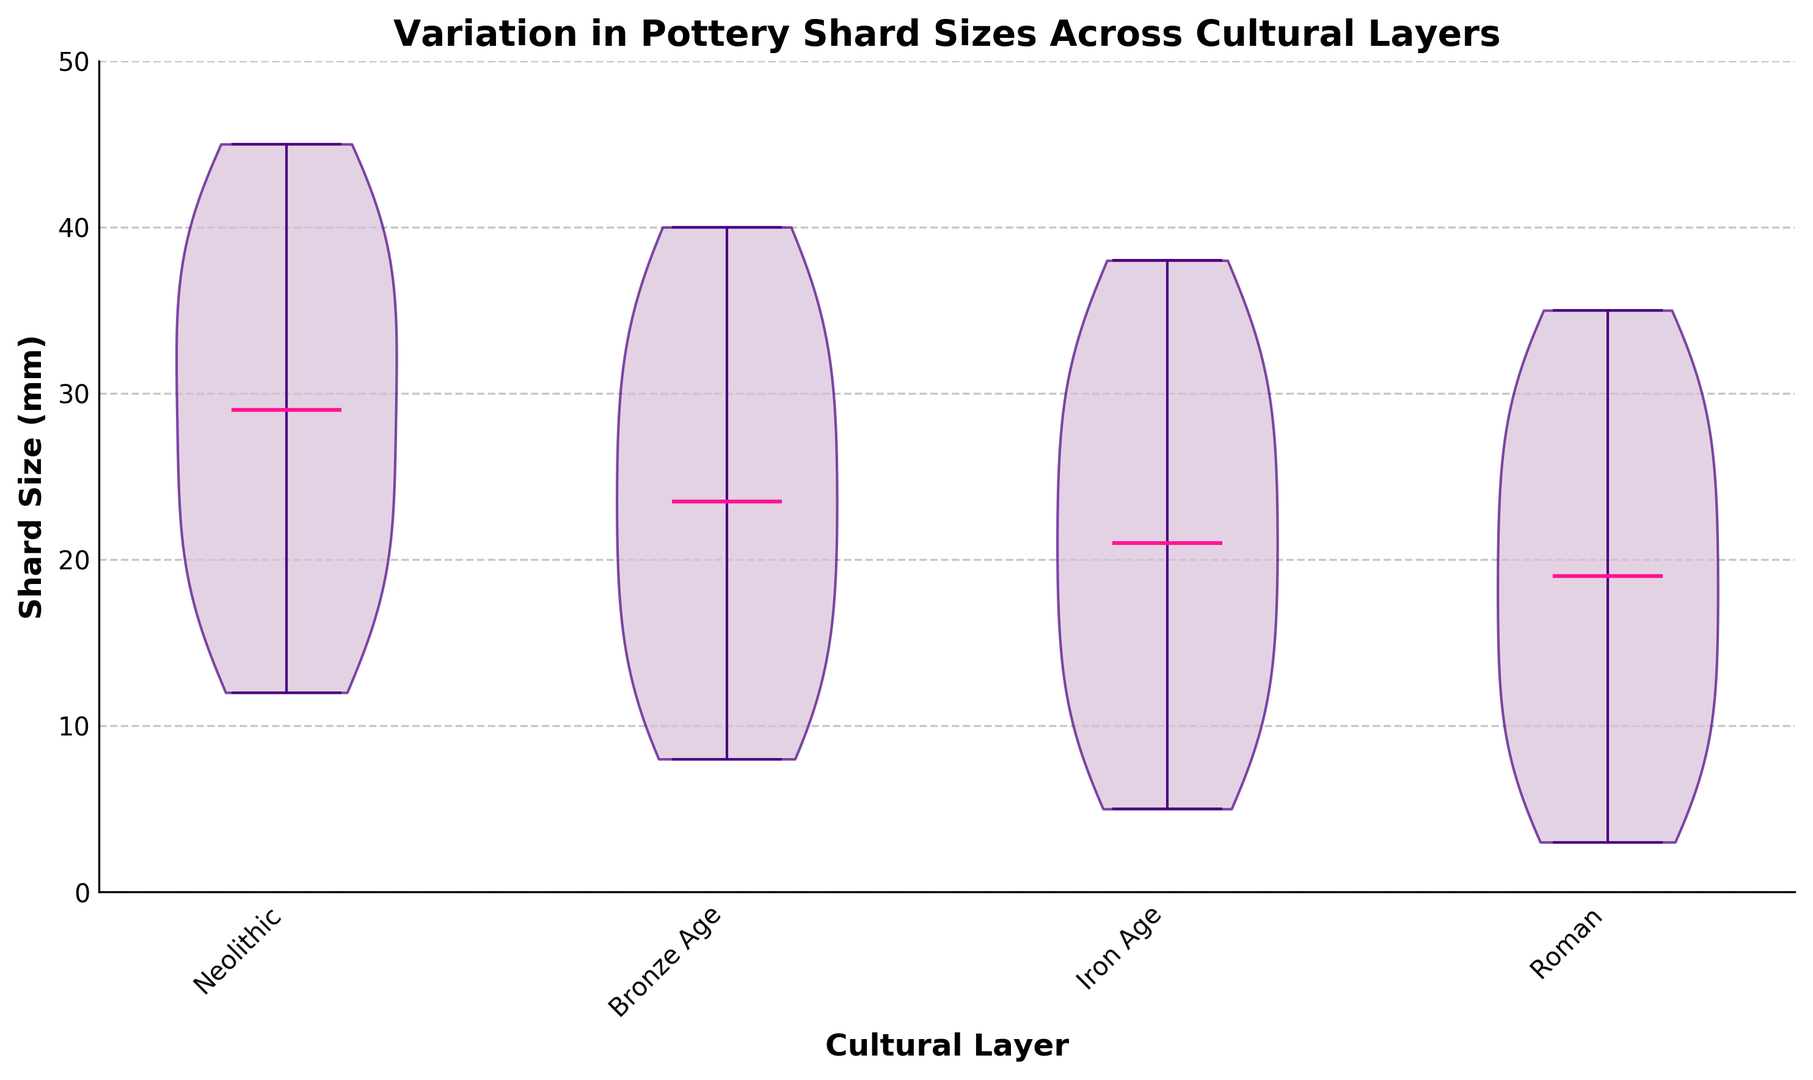What is the median shard size for the Roman cultural layer? The Roman violin plot has a median line inside. The line near the middle of the distribution is the median. If you look at the Roman section, the highest density region shows a median.
Answer: 15 mm Which cultural layer has the smallest median shard size? By comparing the median lines of each violin plot, you can see that the Roman cultural layer has the lowest median among the displayed cultural layers.
Answer: Roman Which cultural layer shows the highest variation in shard sizes? The range of sizes within each cultural layer can be observed by looking at the extent of the distribution in the violin plot. The Neolithic layer has the widest range, extending from 12 mm to 45 mm.
Answer: Neolithic What is the range of shard sizes for the Iron Age cultural layer? The range is the difference between the maximum and minimum shard sizes in the Iron Age distribution. You can see from the plot that Iron Age shard sizes span from 5 mm to 38 mm.
Answer: 33 mm Which cultural layer has a shard size range that overlaps with all other layers? You can determine overlaps by comparing the ranges shown in each violin plot. The Roman cultural layer spans from 3 mm to 35 mm, which overlaps with the ranges of all other cultural layers.
Answer: Roman Which cultural layers have a median shard size greater than 20 mm? By observing the median lines, the Neolithic cultural layer has a median above 20 mm. The other layers’ medians are at or below 20 mm.
Answer: Neolithic Are there any cultural layers with outliers, and how are these visually represented? The presence of outliers in a violin plot can usually be inferred if you see small, isolated points outside the main body of the plot. In this plot, no outliers are explicitly shown.
Answer: None What does the thickness of each violin plot indicate about shard sizes? The thickness or width of the violin plot at different points represents the density of the data. Thicker sections indicate a higher frequency of shard sizes at those points.
Answer: Density of shard sizes 